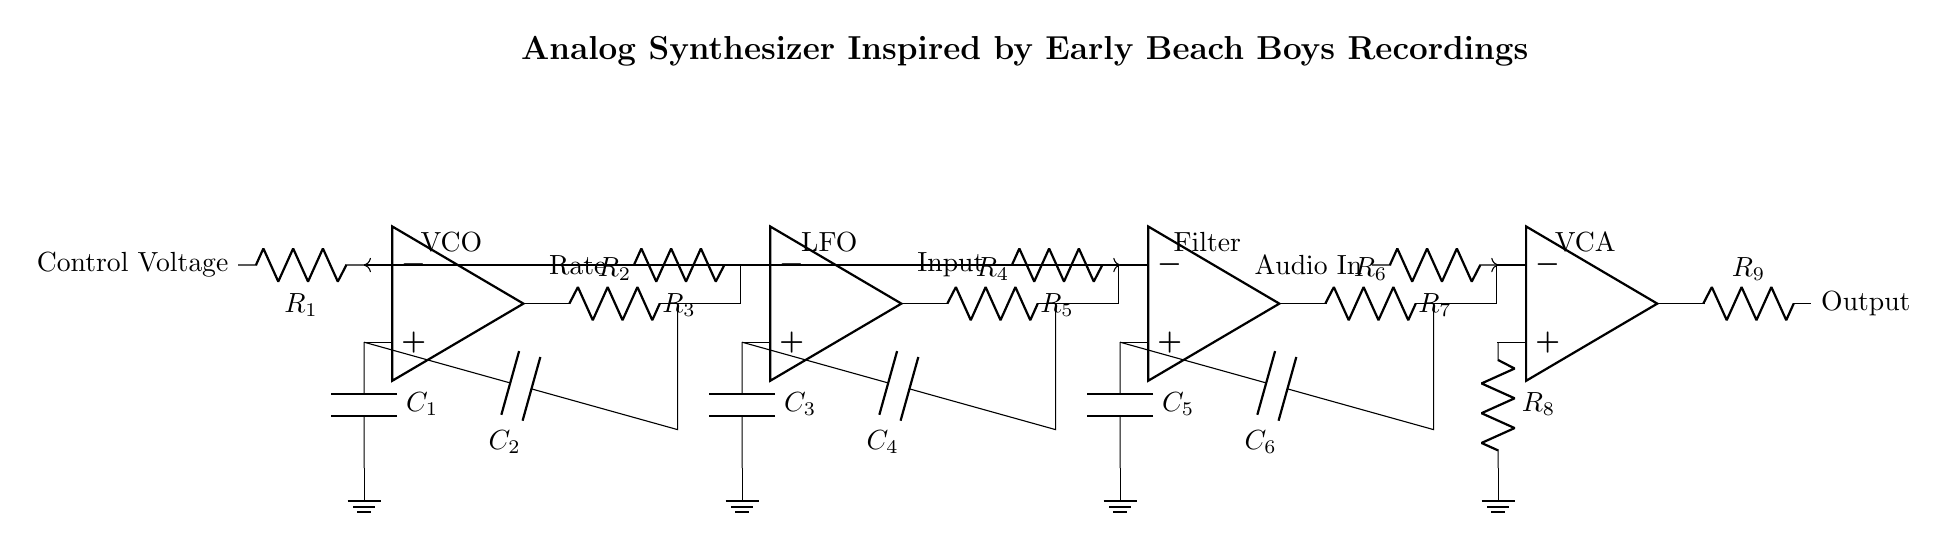What type of circuit is represented? The circuit is an analog synthesizer, which is indicated by the components such as VCO, LFO, Filter, and VCA. These are typical elements found in synthesizer designs for sound generation and modification.
Answer: analog synthesizer How many operational amplifiers are used? There are four operational amplifiers present in the circuit, as evidenced by the four labeled op amp symbols: VCO, LFO, Filter, and VCA.
Answer: four What component values are associated with the VCO? The VCO includes two resistors (R1 and R2) and two capacitors (C1 and C2). R1 and C1 are connected to the control voltage, while R2 and C2 are part of the feedback loop, affecting the oscillation.
Answer: R1, R2, C1, C2 What role does the LFO play in the circuit? The LFO, or Low-Frequency Oscillator, generates modulation signals, which are typically used to control the depth and rate of effects, such as vibrato or tremolo, in synthesizers. It can influence other components like the VCO in this design.
Answer: modulation How does the signal flow from the VCO to the Filter? The output from the VCO (vco_out) is connected to the Filter's non-inverting input (opamp3.-) through a connecting line, which indicates that the signal is routed directly to be processed by the Filter stage.
Answer: directly What types of signals does the VCA control? The VCA, or Voltage-Controlled Amplifier, controls the audio signals entering from "Audio In" and adjusts the final output level before transmission, functioning as the final stage for dynamic sound control.
Answer: audio signals How is the feedback implemented in the circuit? Feedback is implemented through the capacitors (C2, C4, C6) and resistors (R2, R4, R6) in each operational amplifier stage, which creates a path for the output signal to influence the input, essential for stability and gain control in the circuit.
Answer: capacitors and resistors 